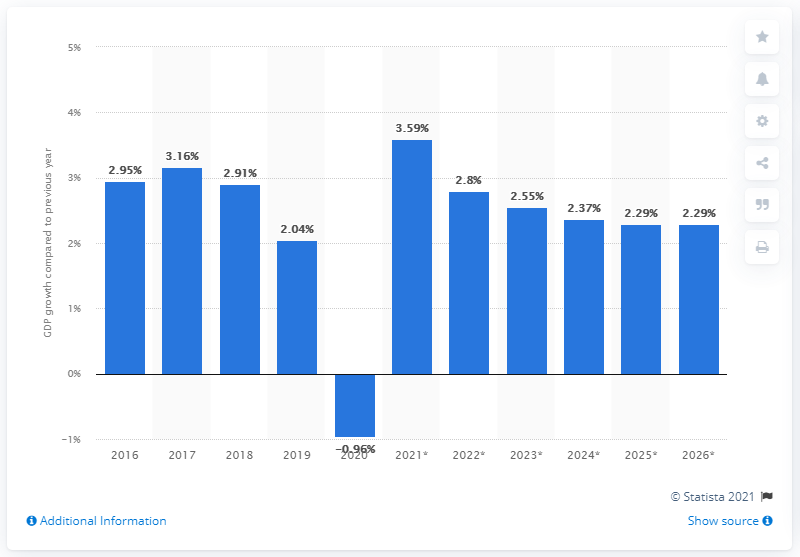Identify some key points in this picture. According to available data, the growth of South Korea's real Gross Domestic Product (GDP) in 2019 was 2.04%. 